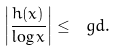<formula> <loc_0><loc_0><loc_500><loc_500>\left | \frac { h ( x ) } { \log x } \right | \leq \ g d .</formula> 